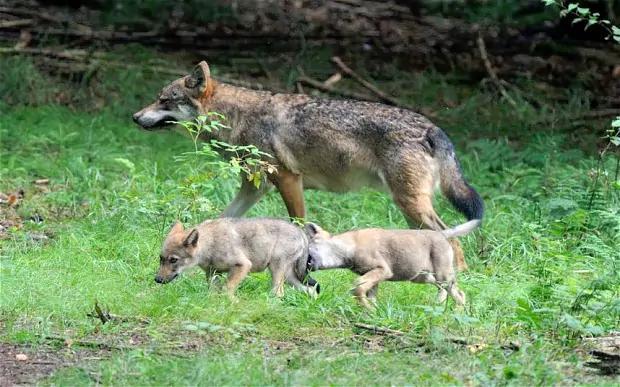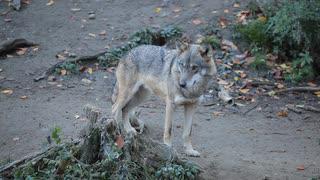The first image is the image on the left, the second image is the image on the right. Examine the images to the left and right. Is the description "The right image contains exactly one wolf." accurate? Answer yes or no. Yes. The first image is the image on the left, the second image is the image on the right. Analyze the images presented: Is the assertion "A herd of buffalo are behind multiple wolves on snow-covered ground in the right image." valid? Answer yes or no. No. 